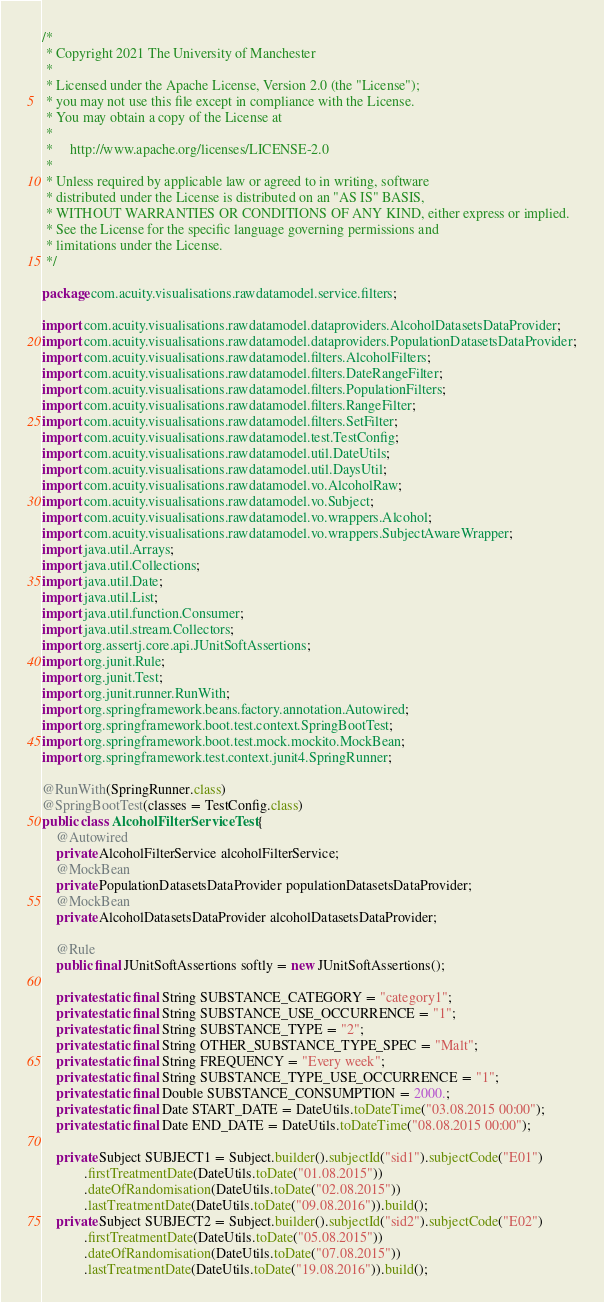Convert code to text. <code><loc_0><loc_0><loc_500><loc_500><_Java_>/*
 * Copyright 2021 The University of Manchester
 *
 * Licensed under the Apache License, Version 2.0 (the "License");
 * you may not use this file except in compliance with the License.
 * You may obtain a copy of the License at
 *
 *     http://www.apache.org/licenses/LICENSE-2.0
 *
 * Unless required by applicable law or agreed to in writing, software
 * distributed under the License is distributed on an "AS IS" BASIS,
 * WITHOUT WARRANTIES OR CONDITIONS OF ANY KIND, either express or implied.
 * See the License for the specific language governing permissions and
 * limitations under the License.
 */

package com.acuity.visualisations.rawdatamodel.service.filters;

import com.acuity.visualisations.rawdatamodel.dataproviders.AlcoholDatasetsDataProvider;
import com.acuity.visualisations.rawdatamodel.dataproviders.PopulationDatasetsDataProvider;
import com.acuity.visualisations.rawdatamodel.filters.AlcoholFilters;
import com.acuity.visualisations.rawdatamodel.filters.DateRangeFilter;
import com.acuity.visualisations.rawdatamodel.filters.PopulationFilters;
import com.acuity.visualisations.rawdatamodel.filters.RangeFilter;
import com.acuity.visualisations.rawdatamodel.filters.SetFilter;
import com.acuity.visualisations.rawdatamodel.test.TestConfig;
import com.acuity.visualisations.rawdatamodel.util.DateUtils;
import com.acuity.visualisations.rawdatamodel.util.DaysUtil;
import com.acuity.visualisations.rawdatamodel.vo.AlcoholRaw;
import com.acuity.visualisations.rawdatamodel.vo.Subject;
import com.acuity.visualisations.rawdatamodel.vo.wrappers.Alcohol;
import com.acuity.visualisations.rawdatamodel.vo.wrappers.SubjectAwareWrapper;
import java.util.Arrays;
import java.util.Collections;
import java.util.Date;
import java.util.List;
import java.util.function.Consumer;
import java.util.stream.Collectors;
import org.assertj.core.api.JUnitSoftAssertions;
import org.junit.Rule;
import org.junit.Test;
import org.junit.runner.RunWith;
import org.springframework.beans.factory.annotation.Autowired;
import org.springframework.boot.test.context.SpringBootTest;
import org.springframework.boot.test.mock.mockito.MockBean;
import org.springframework.test.context.junit4.SpringRunner;

@RunWith(SpringRunner.class)
@SpringBootTest(classes = TestConfig.class)
public class AlcoholFilterServiceTest {
    @Autowired
    private AlcoholFilterService alcoholFilterService;
    @MockBean
    private PopulationDatasetsDataProvider populationDatasetsDataProvider;
    @MockBean
    private AlcoholDatasetsDataProvider alcoholDatasetsDataProvider;

    @Rule
    public final JUnitSoftAssertions softly = new JUnitSoftAssertions();

    private static final String SUBSTANCE_CATEGORY = "category1";
    private static final String SUBSTANCE_USE_OCCURRENCE = "1";
    private static final String SUBSTANCE_TYPE = "2";
    private static final String OTHER_SUBSTANCE_TYPE_SPEC = "Malt";
    private static final String FREQUENCY = "Every week";
    private static final String SUBSTANCE_TYPE_USE_OCCURRENCE = "1";
    private static final Double SUBSTANCE_CONSUMPTION = 2000.;
    private static final Date START_DATE = DateUtils.toDateTime("03.08.2015 00:00");
    private static final Date END_DATE = DateUtils.toDateTime("08.08.2015 00:00");

    private Subject SUBJECT1 = Subject.builder().subjectId("sid1").subjectCode("E01")
            .firstTreatmentDate(DateUtils.toDate("01.08.2015"))
            .dateOfRandomisation(DateUtils.toDate("02.08.2015"))
            .lastTreatmentDate(DateUtils.toDate("09.08.2016")).build();
    private Subject SUBJECT2 = Subject.builder().subjectId("sid2").subjectCode("E02")
            .firstTreatmentDate(DateUtils.toDate("05.08.2015"))
            .dateOfRandomisation(DateUtils.toDate("07.08.2015"))
            .lastTreatmentDate(DateUtils.toDate("19.08.2016")).build();
</code> 